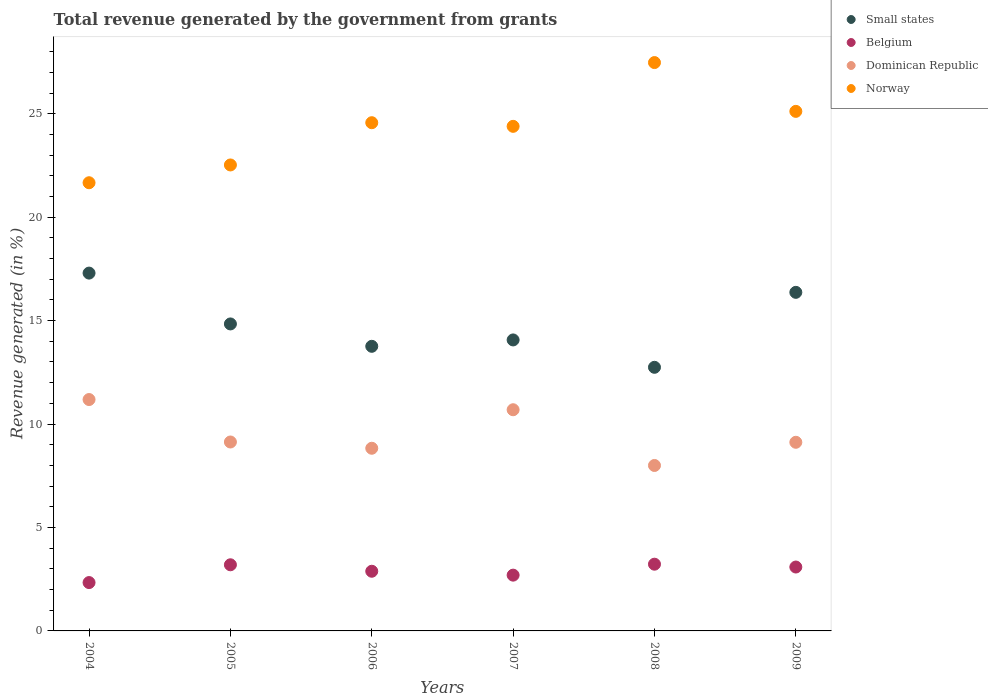How many different coloured dotlines are there?
Keep it short and to the point. 4. What is the total revenue generated in Belgium in 2006?
Make the answer very short. 2.88. Across all years, what is the maximum total revenue generated in Norway?
Keep it short and to the point. 27.47. Across all years, what is the minimum total revenue generated in Dominican Republic?
Keep it short and to the point. 8. In which year was the total revenue generated in Norway maximum?
Provide a short and direct response. 2008. In which year was the total revenue generated in Norway minimum?
Your answer should be very brief. 2004. What is the total total revenue generated in Dominican Republic in the graph?
Provide a succinct answer. 56.95. What is the difference between the total revenue generated in Small states in 2005 and that in 2009?
Offer a very short reply. -1.53. What is the difference between the total revenue generated in Belgium in 2004 and the total revenue generated in Norway in 2009?
Make the answer very short. -22.78. What is the average total revenue generated in Belgium per year?
Your response must be concise. 2.9. In the year 2006, what is the difference between the total revenue generated in Belgium and total revenue generated in Norway?
Make the answer very short. -21.68. In how many years, is the total revenue generated in Dominican Republic greater than 3 %?
Keep it short and to the point. 6. What is the ratio of the total revenue generated in Small states in 2004 to that in 2005?
Give a very brief answer. 1.17. What is the difference between the highest and the second highest total revenue generated in Small states?
Keep it short and to the point. 0.93. What is the difference between the highest and the lowest total revenue generated in Norway?
Ensure brevity in your answer.  5.81. In how many years, is the total revenue generated in Belgium greater than the average total revenue generated in Belgium taken over all years?
Ensure brevity in your answer.  3. Is the sum of the total revenue generated in Dominican Republic in 2004 and 2007 greater than the maximum total revenue generated in Norway across all years?
Provide a short and direct response. No. Is it the case that in every year, the sum of the total revenue generated in Small states and total revenue generated in Belgium  is greater than the total revenue generated in Norway?
Make the answer very short. No. Is the total revenue generated in Norway strictly greater than the total revenue generated in Dominican Republic over the years?
Ensure brevity in your answer.  Yes. Is the total revenue generated in Belgium strictly less than the total revenue generated in Dominican Republic over the years?
Provide a succinct answer. Yes. How many dotlines are there?
Give a very brief answer. 4. Are the values on the major ticks of Y-axis written in scientific E-notation?
Make the answer very short. No. Does the graph contain any zero values?
Give a very brief answer. No. Where does the legend appear in the graph?
Make the answer very short. Top right. How many legend labels are there?
Provide a succinct answer. 4. How are the legend labels stacked?
Provide a succinct answer. Vertical. What is the title of the graph?
Keep it short and to the point. Total revenue generated by the government from grants. Does "Puerto Rico" appear as one of the legend labels in the graph?
Make the answer very short. No. What is the label or title of the Y-axis?
Offer a very short reply. Revenue generated (in %). What is the Revenue generated (in %) in Small states in 2004?
Keep it short and to the point. 17.3. What is the Revenue generated (in %) of Belgium in 2004?
Your answer should be compact. 2.34. What is the Revenue generated (in %) of Dominican Republic in 2004?
Your answer should be compact. 11.18. What is the Revenue generated (in %) in Norway in 2004?
Keep it short and to the point. 21.66. What is the Revenue generated (in %) of Small states in 2005?
Make the answer very short. 14.84. What is the Revenue generated (in %) of Belgium in 2005?
Offer a terse response. 3.2. What is the Revenue generated (in %) of Dominican Republic in 2005?
Ensure brevity in your answer.  9.13. What is the Revenue generated (in %) in Norway in 2005?
Your answer should be compact. 22.52. What is the Revenue generated (in %) of Small states in 2006?
Keep it short and to the point. 13.76. What is the Revenue generated (in %) in Belgium in 2006?
Keep it short and to the point. 2.88. What is the Revenue generated (in %) of Dominican Republic in 2006?
Your response must be concise. 8.83. What is the Revenue generated (in %) in Norway in 2006?
Your answer should be very brief. 24.57. What is the Revenue generated (in %) of Small states in 2007?
Your answer should be compact. 14.07. What is the Revenue generated (in %) of Belgium in 2007?
Your answer should be very brief. 2.7. What is the Revenue generated (in %) of Dominican Republic in 2007?
Your answer should be very brief. 10.69. What is the Revenue generated (in %) of Norway in 2007?
Make the answer very short. 24.39. What is the Revenue generated (in %) in Small states in 2008?
Offer a terse response. 12.74. What is the Revenue generated (in %) in Belgium in 2008?
Give a very brief answer. 3.23. What is the Revenue generated (in %) in Dominican Republic in 2008?
Give a very brief answer. 8. What is the Revenue generated (in %) of Norway in 2008?
Ensure brevity in your answer.  27.47. What is the Revenue generated (in %) of Small states in 2009?
Offer a terse response. 16.37. What is the Revenue generated (in %) of Belgium in 2009?
Give a very brief answer. 3.09. What is the Revenue generated (in %) in Dominican Republic in 2009?
Provide a short and direct response. 9.12. What is the Revenue generated (in %) of Norway in 2009?
Offer a terse response. 25.11. Across all years, what is the maximum Revenue generated (in %) of Small states?
Give a very brief answer. 17.3. Across all years, what is the maximum Revenue generated (in %) of Belgium?
Make the answer very short. 3.23. Across all years, what is the maximum Revenue generated (in %) of Dominican Republic?
Offer a terse response. 11.18. Across all years, what is the maximum Revenue generated (in %) of Norway?
Provide a short and direct response. 27.47. Across all years, what is the minimum Revenue generated (in %) of Small states?
Keep it short and to the point. 12.74. Across all years, what is the minimum Revenue generated (in %) of Belgium?
Your answer should be very brief. 2.34. Across all years, what is the minimum Revenue generated (in %) of Dominican Republic?
Your answer should be very brief. 8. Across all years, what is the minimum Revenue generated (in %) of Norway?
Offer a very short reply. 21.66. What is the total Revenue generated (in %) in Small states in the graph?
Your answer should be compact. 89.06. What is the total Revenue generated (in %) in Belgium in the graph?
Offer a very short reply. 17.43. What is the total Revenue generated (in %) of Dominican Republic in the graph?
Your answer should be compact. 56.95. What is the total Revenue generated (in %) in Norway in the graph?
Provide a short and direct response. 145.73. What is the difference between the Revenue generated (in %) of Small states in 2004 and that in 2005?
Provide a short and direct response. 2.46. What is the difference between the Revenue generated (in %) of Belgium in 2004 and that in 2005?
Keep it short and to the point. -0.86. What is the difference between the Revenue generated (in %) in Dominican Republic in 2004 and that in 2005?
Make the answer very short. 2.05. What is the difference between the Revenue generated (in %) of Norway in 2004 and that in 2005?
Your response must be concise. -0.86. What is the difference between the Revenue generated (in %) in Small states in 2004 and that in 2006?
Make the answer very short. 3.54. What is the difference between the Revenue generated (in %) in Belgium in 2004 and that in 2006?
Provide a short and direct response. -0.55. What is the difference between the Revenue generated (in %) of Dominican Republic in 2004 and that in 2006?
Your response must be concise. 2.35. What is the difference between the Revenue generated (in %) in Norway in 2004 and that in 2006?
Give a very brief answer. -2.9. What is the difference between the Revenue generated (in %) in Small states in 2004 and that in 2007?
Provide a short and direct response. 3.23. What is the difference between the Revenue generated (in %) in Belgium in 2004 and that in 2007?
Your answer should be very brief. -0.36. What is the difference between the Revenue generated (in %) in Dominican Republic in 2004 and that in 2007?
Give a very brief answer. 0.49. What is the difference between the Revenue generated (in %) of Norway in 2004 and that in 2007?
Your answer should be very brief. -2.73. What is the difference between the Revenue generated (in %) of Small states in 2004 and that in 2008?
Offer a very short reply. 4.55. What is the difference between the Revenue generated (in %) in Belgium in 2004 and that in 2008?
Your answer should be very brief. -0.89. What is the difference between the Revenue generated (in %) of Dominican Republic in 2004 and that in 2008?
Give a very brief answer. 3.19. What is the difference between the Revenue generated (in %) in Norway in 2004 and that in 2008?
Provide a short and direct response. -5.81. What is the difference between the Revenue generated (in %) in Small states in 2004 and that in 2009?
Make the answer very short. 0.93. What is the difference between the Revenue generated (in %) of Belgium in 2004 and that in 2009?
Your answer should be compact. -0.75. What is the difference between the Revenue generated (in %) of Dominican Republic in 2004 and that in 2009?
Ensure brevity in your answer.  2.07. What is the difference between the Revenue generated (in %) of Norway in 2004 and that in 2009?
Offer a terse response. -3.45. What is the difference between the Revenue generated (in %) of Small states in 2005 and that in 2006?
Ensure brevity in your answer.  1.08. What is the difference between the Revenue generated (in %) in Belgium in 2005 and that in 2006?
Make the answer very short. 0.31. What is the difference between the Revenue generated (in %) of Dominican Republic in 2005 and that in 2006?
Give a very brief answer. 0.3. What is the difference between the Revenue generated (in %) of Norway in 2005 and that in 2006?
Make the answer very short. -2.04. What is the difference between the Revenue generated (in %) in Small states in 2005 and that in 2007?
Offer a terse response. 0.77. What is the difference between the Revenue generated (in %) in Belgium in 2005 and that in 2007?
Provide a succinct answer. 0.5. What is the difference between the Revenue generated (in %) in Dominican Republic in 2005 and that in 2007?
Offer a very short reply. -1.56. What is the difference between the Revenue generated (in %) of Norway in 2005 and that in 2007?
Your answer should be compact. -1.87. What is the difference between the Revenue generated (in %) in Small states in 2005 and that in 2008?
Provide a short and direct response. 2.1. What is the difference between the Revenue generated (in %) in Belgium in 2005 and that in 2008?
Provide a succinct answer. -0.03. What is the difference between the Revenue generated (in %) of Dominican Republic in 2005 and that in 2008?
Offer a terse response. 1.14. What is the difference between the Revenue generated (in %) of Norway in 2005 and that in 2008?
Provide a short and direct response. -4.95. What is the difference between the Revenue generated (in %) in Small states in 2005 and that in 2009?
Keep it short and to the point. -1.53. What is the difference between the Revenue generated (in %) in Belgium in 2005 and that in 2009?
Provide a succinct answer. 0.11. What is the difference between the Revenue generated (in %) of Dominican Republic in 2005 and that in 2009?
Your answer should be very brief. 0.01. What is the difference between the Revenue generated (in %) in Norway in 2005 and that in 2009?
Ensure brevity in your answer.  -2.59. What is the difference between the Revenue generated (in %) in Small states in 2006 and that in 2007?
Provide a short and direct response. -0.31. What is the difference between the Revenue generated (in %) of Belgium in 2006 and that in 2007?
Offer a very short reply. 0.19. What is the difference between the Revenue generated (in %) of Dominican Republic in 2006 and that in 2007?
Offer a very short reply. -1.86. What is the difference between the Revenue generated (in %) of Norway in 2006 and that in 2007?
Provide a short and direct response. 0.18. What is the difference between the Revenue generated (in %) of Small states in 2006 and that in 2008?
Your response must be concise. 1.01. What is the difference between the Revenue generated (in %) in Belgium in 2006 and that in 2008?
Your answer should be very brief. -0.34. What is the difference between the Revenue generated (in %) in Dominican Republic in 2006 and that in 2008?
Keep it short and to the point. 0.83. What is the difference between the Revenue generated (in %) in Norway in 2006 and that in 2008?
Give a very brief answer. -2.91. What is the difference between the Revenue generated (in %) in Small states in 2006 and that in 2009?
Give a very brief answer. -2.61. What is the difference between the Revenue generated (in %) in Belgium in 2006 and that in 2009?
Offer a very short reply. -0.2. What is the difference between the Revenue generated (in %) of Dominican Republic in 2006 and that in 2009?
Offer a very short reply. -0.29. What is the difference between the Revenue generated (in %) of Norway in 2006 and that in 2009?
Provide a succinct answer. -0.55. What is the difference between the Revenue generated (in %) of Small states in 2007 and that in 2008?
Provide a short and direct response. 1.32. What is the difference between the Revenue generated (in %) in Belgium in 2007 and that in 2008?
Offer a terse response. -0.53. What is the difference between the Revenue generated (in %) in Dominican Republic in 2007 and that in 2008?
Make the answer very short. 2.69. What is the difference between the Revenue generated (in %) of Norway in 2007 and that in 2008?
Provide a succinct answer. -3.08. What is the difference between the Revenue generated (in %) of Small states in 2007 and that in 2009?
Your response must be concise. -2.3. What is the difference between the Revenue generated (in %) of Belgium in 2007 and that in 2009?
Make the answer very short. -0.39. What is the difference between the Revenue generated (in %) of Dominican Republic in 2007 and that in 2009?
Your answer should be very brief. 1.57. What is the difference between the Revenue generated (in %) in Norway in 2007 and that in 2009?
Make the answer very short. -0.72. What is the difference between the Revenue generated (in %) in Small states in 2008 and that in 2009?
Provide a succinct answer. -3.62. What is the difference between the Revenue generated (in %) of Belgium in 2008 and that in 2009?
Provide a succinct answer. 0.14. What is the difference between the Revenue generated (in %) in Dominican Republic in 2008 and that in 2009?
Give a very brief answer. -1.12. What is the difference between the Revenue generated (in %) in Norway in 2008 and that in 2009?
Provide a succinct answer. 2.36. What is the difference between the Revenue generated (in %) in Small states in 2004 and the Revenue generated (in %) in Belgium in 2005?
Provide a succinct answer. 14.1. What is the difference between the Revenue generated (in %) of Small states in 2004 and the Revenue generated (in %) of Dominican Republic in 2005?
Provide a short and direct response. 8.16. What is the difference between the Revenue generated (in %) of Small states in 2004 and the Revenue generated (in %) of Norway in 2005?
Your answer should be compact. -5.23. What is the difference between the Revenue generated (in %) in Belgium in 2004 and the Revenue generated (in %) in Dominican Republic in 2005?
Offer a very short reply. -6.79. What is the difference between the Revenue generated (in %) in Belgium in 2004 and the Revenue generated (in %) in Norway in 2005?
Ensure brevity in your answer.  -20.19. What is the difference between the Revenue generated (in %) of Dominican Republic in 2004 and the Revenue generated (in %) of Norway in 2005?
Provide a short and direct response. -11.34. What is the difference between the Revenue generated (in %) in Small states in 2004 and the Revenue generated (in %) in Belgium in 2006?
Your answer should be very brief. 14.41. What is the difference between the Revenue generated (in %) in Small states in 2004 and the Revenue generated (in %) in Dominican Republic in 2006?
Provide a succinct answer. 8.47. What is the difference between the Revenue generated (in %) of Small states in 2004 and the Revenue generated (in %) of Norway in 2006?
Ensure brevity in your answer.  -7.27. What is the difference between the Revenue generated (in %) of Belgium in 2004 and the Revenue generated (in %) of Dominican Republic in 2006?
Your response must be concise. -6.49. What is the difference between the Revenue generated (in %) in Belgium in 2004 and the Revenue generated (in %) in Norway in 2006?
Provide a succinct answer. -22.23. What is the difference between the Revenue generated (in %) of Dominican Republic in 2004 and the Revenue generated (in %) of Norway in 2006?
Your answer should be very brief. -13.38. What is the difference between the Revenue generated (in %) in Small states in 2004 and the Revenue generated (in %) in Belgium in 2007?
Your response must be concise. 14.6. What is the difference between the Revenue generated (in %) of Small states in 2004 and the Revenue generated (in %) of Dominican Republic in 2007?
Keep it short and to the point. 6.61. What is the difference between the Revenue generated (in %) of Small states in 2004 and the Revenue generated (in %) of Norway in 2007?
Your answer should be very brief. -7.09. What is the difference between the Revenue generated (in %) of Belgium in 2004 and the Revenue generated (in %) of Dominican Republic in 2007?
Keep it short and to the point. -8.35. What is the difference between the Revenue generated (in %) of Belgium in 2004 and the Revenue generated (in %) of Norway in 2007?
Your answer should be very brief. -22.05. What is the difference between the Revenue generated (in %) in Dominican Republic in 2004 and the Revenue generated (in %) in Norway in 2007?
Make the answer very short. -13.21. What is the difference between the Revenue generated (in %) in Small states in 2004 and the Revenue generated (in %) in Belgium in 2008?
Your answer should be compact. 14.07. What is the difference between the Revenue generated (in %) in Small states in 2004 and the Revenue generated (in %) in Dominican Republic in 2008?
Your answer should be very brief. 9.3. What is the difference between the Revenue generated (in %) in Small states in 2004 and the Revenue generated (in %) in Norway in 2008?
Ensure brevity in your answer.  -10.18. What is the difference between the Revenue generated (in %) in Belgium in 2004 and the Revenue generated (in %) in Dominican Republic in 2008?
Your answer should be very brief. -5.66. What is the difference between the Revenue generated (in %) in Belgium in 2004 and the Revenue generated (in %) in Norway in 2008?
Make the answer very short. -25.13. What is the difference between the Revenue generated (in %) of Dominican Republic in 2004 and the Revenue generated (in %) of Norway in 2008?
Make the answer very short. -16.29. What is the difference between the Revenue generated (in %) of Small states in 2004 and the Revenue generated (in %) of Belgium in 2009?
Your answer should be compact. 14.21. What is the difference between the Revenue generated (in %) of Small states in 2004 and the Revenue generated (in %) of Dominican Republic in 2009?
Your response must be concise. 8.18. What is the difference between the Revenue generated (in %) in Small states in 2004 and the Revenue generated (in %) in Norway in 2009?
Your answer should be very brief. -7.82. What is the difference between the Revenue generated (in %) of Belgium in 2004 and the Revenue generated (in %) of Dominican Republic in 2009?
Your answer should be compact. -6.78. What is the difference between the Revenue generated (in %) of Belgium in 2004 and the Revenue generated (in %) of Norway in 2009?
Offer a terse response. -22.78. What is the difference between the Revenue generated (in %) in Dominican Republic in 2004 and the Revenue generated (in %) in Norway in 2009?
Offer a very short reply. -13.93. What is the difference between the Revenue generated (in %) of Small states in 2005 and the Revenue generated (in %) of Belgium in 2006?
Your answer should be very brief. 11.95. What is the difference between the Revenue generated (in %) in Small states in 2005 and the Revenue generated (in %) in Dominican Republic in 2006?
Keep it short and to the point. 6.01. What is the difference between the Revenue generated (in %) in Small states in 2005 and the Revenue generated (in %) in Norway in 2006?
Give a very brief answer. -9.73. What is the difference between the Revenue generated (in %) in Belgium in 2005 and the Revenue generated (in %) in Dominican Republic in 2006?
Give a very brief answer. -5.63. What is the difference between the Revenue generated (in %) of Belgium in 2005 and the Revenue generated (in %) of Norway in 2006?
Give a very brief answer. -21.37. What is the difference between the Revenue generated (in %) of Dominican Republic in 2005 and the Revenue generated (in %) of Norway in 2006?
Your answer should be compact. -15.43. What is the difference between the Revenue generated (in %) of Small states in 2005 and the Revenue generated (in %) of Belgium in 2007?
Ensure brevity in your answer.  12.14. What is the difference between the Revenue generated (in %) in Small states in 2005 and the Revenue generated (in %) in Dominican Republic in 2007?
Keep it short and to the point. 4.15. What is the difference between the Revenue generated (in %) in Small states in 2005 and the Revenue generated (in %) in Norway in 2007?
Your answer should be compact. -9.55. What is the difference between the Revenue generated (in %) of Belgium in 2005 and the Revenue generated (in %) of Dominican Republic in 2007?
Your answer should be very brief. -7.49. What is the difference between the Revenue generated (in %) in Belgium in 2005 and the Revenue generated (in %) in Norway in 2007?
Offer a very short reply. -21.19. What is the difference between the Revenue generated (in %) in Dominican Republic in 2005 and the Revenue generated (in %) in Norway in 2007?
Your answer should be very brief. -15.26. What is the difference between the Revenue generated (in %) in Small states in 2005 and the Revenue generated (in %) in Belgium in 2008?
Provide a short and direct response. 11.61. What is the difference between the Revenue generated (in %) of Small states in 2005 and the Revenue generated (in %) of Dominican Republic in 2008?
Your response must be concise. 6.84. What is the difference between the Revenue generated (in %) of Small states in 2005 and the Revenue generated (in %) of Norway in 2008?
Provide a short and direct response. -12.63. What is the difference between the Revenue generated (in %) of Belgium in 2005 and the Revenue generated (in %) of Dominican Republic in 2008?
Give a very brief answer. -4.8. What is the difference between the Revenue generated (in %) of Belgium in 2005 and the Revenue generated (in %) of Norway in 2008?
Provide a short and direct response. -24.28. What is the difference between the Revenue generated (in %) of Dominican Republic in 2005 and the Revenue generated (in %) of Norway in 2008?
Make the answer very short. -18.34. What is the difference between the Revenue generated (in %) of Small states in 2005 and the Revenue generated (in %) of Belgium in 2009?
Ensure brevity in your answer.  11.75. What is the difference between the Revenue generated (in %) in Small states in 2005 and the Revenue generated (in %) in Dominican Republic in 2009?
Ensure brevity in your answer.  5.72. What is the difference between the Revenue generated (in %) of Small states in 2005 and the Revenue generated (in %) of Norway in 2009?
Your response must be concise. -10.27. What is the difference between the Revenue generated (in %) in Belgium in 2005 and the Revenue generated (in %) in Dominican Republic in 2009?
Give a very brief answer. -5.92. What is the difference between the Revenue generated (in %) of Belgium in 2005 and the Revenue generated (in %) of Norway in 2009?
Provide a succinct answer. -21.92. What is the difference between the Revenue generated (in %) of Dominican Republic in 2005 and the Revenue generated (in %) of Norway in 2009?
Keep it short and to the point. -15.98. What is the difference between the Revenue generated (in %) in Small states in 2006 and the Revenue generated (in %) in Belgium in 2007?
Offer a terse response. 11.06. What is the difference between the Revenue generated (in %) of Small states in 2006 and the Revenue generated (in %) of Dominican Republic in 2007?
Provide a short and direct response. 3.07. What is the difference between the Revenue generated (in %) in Small states in 2006 and the Revenue generated (in %) in Norway in 2007?
Make the answer very short. -10.63. What is the difference between the Revenue generated (in %) of Belgium in 2006 and the Revenue generated (in %) of Dominican Republic in 2007?
Keep it short and to the point. -7.81. What is the difference between the Revenue generated (in %) in Belgium in 2006 and the Revenue generated (in %) in Norway in 2007?
Offer a terse response. -21.51. What is the difference between the Revenue generated (in %) in Dominican Republic in 2006 and the Revenue generated (in %) in Norway in 2007?
Provide a short and direct response. -15.56. What is the difference between the Revenue generated (in %) in Small states in 2006 and the Revenue generated (in %) in Belgium in 2008?
Ensure brevity in your answer.  10.53. What is the difference between the Revenue generated (in %) of Small states in 2006 and the Revenue generated (in %) of Dominican Republic in 2008?
Ensure brevity in your answer.  5.76. What is the difference between the Revenue generated (in %) in Small states in 2006 and the Revenue generated (in %) in Norway in 2008?
Your answer should be compact. -13.71. What is the difference between the Revenue generated (in %) in Belgium in 2006 and the Revenue generated (in %) in Dominican Republic in 2008?
Your response must be concise. -5.11. What is the difference between the Revenue generated (in %) in Belgium in 2006 and the Revenue generated (in %) in Norway in 2008?
Offer a very short reply. -24.59. What is the difference between the Revenue generated (in %) in Dominican Republic in 2006 and the Revenue generated (in %) in Norway in 2008?
Keep it short and to the point. -18.64. What is the difference between the Revenue generated (in %) of Small states in 2006 and the Revenue generated (in %) of Belgium in 2009?
Make the answer very short. 10.67. What is the difference between the Revenue generated (in %) in Small states in 2006 and the Revenue generated (in %) in Dominican Republic in 2009?
Offer a terse response. 4.64. What is the difference between the Revenue generated (in %) in Small states in 2006 and the Revenue generated (in %) in Norway in 2009?
Offer a terse response. -11.36. What is the difference between the Revenue generated (in %) of Belgium in 2006 and the Revenue generated (in %) of Dominican Republic in 2009?
Give a very brief answer. -6.23. What is the difference between the Revenue generated (in %) of Belgium in 2006 and the Revenue generated (in %) of Norway in 2009?
Provide a short and direct response. -22.23. What is the difference between the Revenue generated (in %) of Dominican Republic in 2006 and the Revenue generated (in %) of Norway in 2009?
Offer a terse response. -16.28. What is the difference between the Revenue generated (in %) in Small states in 2007 and the Revenue generated (in %) in Belgium in 2008?
Offer a terse response. 10.84. What is the difference between the Revenue generated (in %) in Small states in 2007 and the Revenue generated (in %) in Dominican Republic in 2008?
Ensure brevity in your answer.  6.07. What is the difference between the Revenue generated (in %) of Small states in 2007 and the Revenue generated (in %) of Norway in 2008?
Your answer should be very brief. -13.41. What is the difference between the Revenue generated (in %) of Belgium in 2007 and the Revenue generated (in %) of Dominican Republic in 2008?
Your answer should be compact. -5.3. What is the difference between the Revenue generated (in %) of Belgium in 2007 and the Revenue generated (in %) of Norway in 2008?
Make the answer very short. -24.78. What is the difference between the Revenue generated (in %) in Dominican Republic in 2007 and the Revenue generated (in %) in Norway in 2008?
Make the answer very short. -16.78. What is the difference between the Revenue generated (in %) of Small states in 2007 and the Revenue generated (in %) of Belgium in 2009?
Offer a very short reply. 10.98. What is the difference between the Revenue generated (in %) in Small states in 2007 and the Revenue generated (in %) in Dominican Republic in 2009?
Ensure brevity in your answer.  4.95. What is the difference between the Revenue generated (in %) of Small states in 2007 and the Revenue generated (in %) of Norway in 2009?
Offer a terse response. -11.05. What is the difference between the Revenue generated (in %) of Belgium in 2007 and the Revenue generated (in %) of Dominican Republic in 2009?
Ensure brevity in your answer.  -6.42. What is the difference between the Revenue generated (in %) in Belgium in 2007 and the Revenue generated (in %) in Norway in 2009?
Make the answer very short. -22.42. What is the difference between the Revenue generated (in %) in Dominican Republic in 2007 and the Revenue generated (in %) in Norway in 2009?
Your answer should be very brief. -14.42. What is the difference between the Revenue generated (in %) of Small states in 2008 and the Revenue generated (in %) of Belgium in 2009?
Your answer should be very brief. 9.65. What is the difference between the Revenue generated (in %) of Small states in 2008 and the Revenue generated (in %) of Dominican Republic in 2009?
Your answer should be compact. 3.62. What is the difference between the Revenue generated (in %) in Small states in 2008 and the Revenue generated (in %) in Norway in 2009?
Keep it short and to the point. -12.37. What is the difference between the Revenue generated (in %) of Belgium in 2008 and the Revenue generated (in %) of Dominican Republic in 2009?
Offer a terse response. -5.89. What is the difference between the Revenue generated (in %) in Belgium in 2008 and the Revenue generated (in %) in Norway in 2009?
Offer a terse response. -21.89. What is the difference between the Revenue generated (in %) in Dominican Republic in 2008 and the Revenue generated (in %) in Norway in 2009?
Offer a terse response. -17.12. What is the average Revenue generated (in %) of Small states per year?
Your answer should be compact. 14.84. What is the average Revenue generated (in %) of Belgium per year?
Your answer should be compact. 2.9. What is the average Revenue generated (in %) of Dominican Republic per year?
Offer a very short reply. 9.49. What is the average Revenue generated (in %) of Norway per year?
Your answer should be compact. 24.29. In the year 2004, what is the difference between the Revenue generated (in %) of Small states and Revenue generated (in %) of Belgium?
Give a very brief answer. 14.96. In the year 2004, what is the difference between the Revenue generated (in %) in Small states and Revenue generated (in %) in Dominican Republic?
Provide a short and direct response. 6.11. In the year 2004, what is the difference between the Revenue generated (in %) in Small states and Revenue generated (in %) in Norway?
Offer a very short reply. -4.37. In the year 2004, what is the difference between the Revenue generated (in %) in Belgium and Revenue generated (in %) in Dominican Republic?
Provide a short and direct response. -8.85. In the year 2004, what is the difference between the Revenue generated (in %) of Belgium and Revenue generated (in %) of Norway?
Provide a short and direct response. -19.33. In the year 2004, what is the difference between the Revenue generated (in %) of Dominican Republic and Revenue generated (in %) of Norway?
Your response must be concise. -10.48. In the year 2005, what is the difference between the Revenue generated (in %) of Small states and Revenue generated (in %) of Belgium?
Your answer should be compact. 11.64. In the year 2005, what is the difference between the Revenue generated (in %) of Small states and Revenue generated (in %) of Dominican Republic?
Keep it short and to the point. 5.71. In the year 2005, what is the difference between the Revenue generated (in %) in Small states and Revenue generated (in %) in Norway?
Your answer should be very brief. -7.68. In the year 2005, what is the difference between the Revenue generated (in %) of Belgium and Revenue generated (in %) of Dominican Republic?
Make the answer very short. -5.94. In the year 2005, what is the difference between the Revenue generated (in %) in Belgium and Revenue generated (in %) in Norway?
Your answer should be compact. -19.33. In the year 2005, what is the difference between the Revenue generated (in %) of Dominican Republic and Revenue generated (in %) of Norway?
Provide a short and direct response. -13.39. In the year 2006, what is the difference between the Revenue generated (in %) in Small states and Revenue generated (in %) in Belgium?
Make the answer very short. 10.87. In the year 2006, what is the difference between the Revenue generated (in %) of Small states and Revenue generated (in %) of Dominican Republic?
Provide a succinct answer. 4.93. In the year 2006, what is the difference between the Revenue generated (in %) of Small states and Revenue generated (in %) of Norway?
Keep it short and to the point. -10.81. In the year 2006, what is the difference between the Revenue generated (in %) of Belgium and Revenue generated (in %) of Dominican Republic?
Keep it short and to the point. -5.95. In the year 2006, what is the difference between the Revenue generated (in %) of Belgium and Revenue generated (in %) of Norway?
Provide a short and direct response. -21.68. In the year 2006, what is the difference between the Revenue generated (in %) of Dominican Republic and Revenue generated (in %) of Norway?
Offer a very short reply. -15.74. In the year 2007, what is the difference between the Revenue generated (in %) of Small states and Revenue generated (in %) of Belgium?
Provide a short and direct response. 11.37. In the year 2007, what is the difference between the Revenue generated (in %) in Small states and Revenue generated (in %) in Dominican Republic?
Make the answer very short. 3.37. In the year 2007, what is the difference between the Revenue generated (in %) in Small states and Revenue generated (in %) in Norway?
Offer a very short reply. -10.32. In the year 2007, what is the difference between the Revenue generated (in %) of Belgium and Revenue generated (in %) of Dominican Republic?
Keep it short and to the point. -7.99. In the year 2007, what is the difference between the Revenue generated (in %) in Belgium and Revenue generated (in %) in Norway?
Offer a very short reply. -21.69. In the year 2007, what is the difference between the Revenue generated (in %) in Dominican Republic and Revenue generated (in %) in Norway?
Keep it short and to the point. -13.7. In the year 2008, what is the difference between the Revenue generated (in %) of Small states and Revenue generated (in %) of Belgium?
Provide a short and direct response. 9.52. In the year 2008, what is the difference between the Revenue generated (in %) of Small states and Revenue generated (in %) of Dominican Republic?
Keep it short and to the point. 4.75. In the year 2008, what is the difference between the Revenue generated (in %) of Small states and Revenue generated (in %) of Norway?
Your response must be concise. -14.73. In the year 2008, what is the difference between the Revenue generated (in %) of Belgium and Revenue generated (in %) of Dominican Republic?
Provide a short and direct response. -4.77. In the year 2008, what is the difference between the Revenue generated (in %) of Belgium and Revenue generated (in %) of Norway?
Your answer should be compact. -24.25. In the year 2008, what is the difference between the Revenue generated (in %) of Dominican Republic and Revenue generated (in %) of Norway?
Provide a short and direct response. -19.47. In the year 2009, what is the difference between the Revenue generated (in %) in Small states and Revenue generated (in %) in Belgium?
Your answer should be compact. 13.28. In the year 2009, what is the difference between the Revenue generated (in %) in Small states and Revenue generated (in %) in Dominican Republic?
Your answer should be compact. 7.25. In the year 2009, what is the difference between the Revenue generated (in %) in Small states and Revenue generated (in %) in Norway?
Offer a very short reply. -8.75. In the year 2009, what is the difference between the Revenue generated (in %) in Belgium and Revenue generated (in %) in Dominican Republic?
Make the answer very short. -6.03. In the year 2009, what is the difference between the Revenue generated (in %) of Belgium and Revenue generated (in %) of Norway?
Offer a terse response. -22.03. In the year 2009, what is the difference between the Revenue generated (in %) in Dominican Republic and Revenue generated (in %) in Norway?
Offer a terse response. -16. What is the ratio of the Revenue generated (in %) of Small states in 2004 to that in 2005?
Make the answer very short. 1.17. What is the ratio of the Revenue generated (in %) of Belgium in 2004 to that in 2005?
Your answer should be compact. 0.73. What is the ratio of the Revenue generated (in %) in Dominican Republic in 2004 to that in 2005?
Keep it short and to the point. 1.22. What is the ratio of the Revenue generated (in %) of Norway in 2004 to that in 2005?
Make the answer very short. 0.96. What is the ratio of the Revenue generated (in %) of Small states in 2004 to that in 2006?
Your answer should be compact. 1.26. What is the ratio of the Revenue generated (in %) of Belgium in 2004 to that in 2006?
Ensure brevity in your answer.  0.81. What is the ratio of the Revenue generated (in %) of Dominican Republic in 2004 to that in 2006?
Provide a short and direct response. 1.27. What is the ratio of the Revenue generated (in %) in Norway in 2004 to that in 2006?
Provide a succinct answer. 0.88. What is the ratio of the Revenue generated (in %) of Small states in 2004 to that in 2007?
Give a very brief answer. 1.23. What is the ratio of the Revenue generated (in %) in Belgium in 2004 to that in 2007?
Your answer should be compact. 0.87. What is the ratio of the Revenue generated (in %) in Dominican Republic in 2004 to that in 2007?
Offer a terse response. 1.05. What is the ratio of the Revenue generated (in %) of Norway in 2004 to that in 2007?
Offer a terse response. 0.89. What is the ratio of the Revenue generated (in %) in Small states in 2004 to that in 2008?
Your answer should be very brief. 1.36. What is the ratio of the Revenue generated (in %) in Belgium in 2004 to that in 2008?
Keep it short and to the point. 0.72. What is the ratio of the Revenue generated (in %) of Dominican Republic in 2004 to that in 2008?
Give a very brief answer. 1.4. What is the ratio of the Revenue generated (in %) in Norway in 2004 to that in 2008?
Your response must be concise. 0.79. What is the ratio of the Revenue generated (in %) of Small states in 2004 to that in 2009?
Your response must be concise. 1.06. What is the ratio of the Revenue generated (in %) in Belgium in 2004 to that in 2009?
Offer a terse response. 0.76. What is the ratio of the Revenue generated (in %) of Dominican Republic in 2004 to that in 2009?
Your response must be concise. 1.23. What is the ratio of the Revenue generated (in %) in Norway in 2004 to that in 2009?
Offer a very short reply. 0.86. What is the ratio of the Revenue generated (in %) of Small states in 2005 to that in 2006?
Your answer should be very brief. 1.08. What is the ratio of the Revenue generated (in %) in Belgium in 2005 to that in 2006?
Provide a succinct answer. 1.11. What is the ratio of the Revenue generated (in %) in Dominican Republic in 2005 to that in 2006?
Provide a short and direct response. 1.03. What is the ratio of the Revenue generated (in %) in Norway in 2005 to that in 2006?
Offer a terse response. 0.92. What is the ratio of the Revenue generated (in %) in Small states in 2005 to that in 2007?
Offer a very short reply. 1.05. What is the ratio of the Revenue generated (in %) of Belgium in 2005 to that in 2007?
Provide a short and direct response. 1.19. What is the ratio of the Revenue generated (in %) of Dominican Republic in 2005 to that in 2007?
Your answer should be very brief. 0.85. What is the ratio of the Revenue generated (in %) of Norway in 2005 to that in 2007?
Provide a short and direct response. 0.92. What is the ratio of the Revenue generated (in %) in Small states in 2005 to that in 2008?
Provide a succinct answer. 1.16. What is the ratio of the Revenue generated (in %) of Dominican Republic in 2005 to that in 2008?
Your answer should be compact. 1.14. What is the ratio of the Revenue generated (in %) of Norway in 2005 to that in 2008?
Keep it short and to the point. 0.82. What is the ratio of the Revenue generated (in %) in Small states in 2005 to that in 2009?
Give a very brief answer. 0.91. What is the ratio of the Revenue generated (in %) of Belgium in 2005 to that in 2009?
Keep it short and to the point. 1.04. What is the ratio of the Revenue generated (in %) of Dominican Republic in 2005 to that in 2009?
Keep it short and to the point. 1. What is the ratio of the Revenue generated (in %) of Norway in 2005 to that in 2009?
Your answer should be compact. 0.9. What is the ratio of the Revenue generated (in %) of Small states in 2006 to that in 2007?
Provide a short and direct response. 0.98. What is the ratio of the Revenue generated (in %) in Belgium in 2006 to that in 2007?
Provide a succinct answer. 1.07. What is the ratio of the Revenue generated (in %) in Dominican Republic in 2006 to that in 2007?
Keep it short and to the point. 0.83. What is the ratio of the Revenue generated (in %) of Small states in 2006 to that in 2008?
Your answer should be very brief. 1.08. What is the ratio of the Revenue generated (in %) of Belgium in 2006 to that in 2008?
Ensure brevity in your answer.  0.89. What is the ratio of the Revenue generated (in %) of Dominican Republic in 2006 to that in 2008?
Your response must be concise. 1.1. What is the ratio of the Revenue generated (in %) in Norway in 2006 to that in 2008?
Provide a short and direct response. 0.89. What is the ratio of the Revenue generated (in %) in Small states in 2006 to that in 2009?
Give a very brief answer. 0.84. What is the ratio of the Revenue generated (in %) in Belgium in 2006 to that in 2009?
Ensure brevity in your answer.  0.93. What is the ratio of the Revenue generated (in %) in Dominican Republic in 2006 to that in 2009?
Your answer should be very brief. 0.97. What is the ratio of the Revenue generated (in %) of Norway in 2006 to that in 2009?
Offer a very short reply. 0.98. What is the ratio of the Revenue generated (in %) of Small states in 2007 to that in 2008?
Your response must be concise. 1.1. What is the ratio of the Revenue generated (in %) in Belgium in 2007 to that in 2008?
Make the answer very short. 0.84. What is the ratio of the Revenue generated (in %) in Dominican Republic in 2007 to that in 2008?
Give a very brief answer. 1.34. What is the ratio of the Revenue generated (in %) of Norway in 2007 to that in 2008?
Your answer should be very brief. 0.89. What is the ratio of the Revenue generated (in %) of Small states in 2007 to that in 2009?
Keep it short and to the point. 0.86. What is the ratio of the Revenue generated (in %) in Belgium in 2007 to that in 2009?
Your answer should be very brief. 0.87. What is the ratio of the Revenue generated (in %) of Dominican Republic in 2007 to that in 2009?
Offer a terse response. 1.17. What is the ratio of the Revenue generated (in %) in Norway in 2007 to that in 2009?
Keep it short and to the point. 0.97. What is the ratio of the Revenue generated (in %) of Small states in 2008 to that in 2009?
Keep it short and to the point. 0.78. What is the ratio of the Revenue generated (in %) in Belgium in 2008 to that in 2009?
Ensure brevity in your answer.  1.04. What is the ratio of the Revenue generated (in %) of Dominican Republic in 2008 to that in 2009?
Ensure brevity in your answer.  0.88. What is the ratio of the Revenue generated (in %) in Norway in 2008 to that in 2009?
Make the answer very short. 1.09. What is the difference between the highest and the second highest Revenue generated (in %) in Small states?
Make the answer very short. 0.93. What is the difference between the highest and the second highest Revenue generated (in %) of Belgium?
Provide a succinct answer. 0.03. What is the difference between the highest and the second highest Revenue generated (in %) in Dominican Republic?
Your response must be concise. 0.49. What is the difference between the highest and the second highest Revenue generated (in %) of Norway?
Offer a terse response. 2.36. What is the difference between the highest and the lowest Revenue generated (in %) of Small states?
Your response must be concise. 4.55. What is the difference between the highest and the lowest Revenue generated (in %) of Belgium?
Your response must be concise. 0.89. What is the difference between the highest and the lowest Revenue generated (in %) in Dominican Republic?
Provide a succinct answer. 3.19. What is the difference between the highest and the lowest Revenue generated (in %) in Norway?
Provide a short and direct response. 5.81. 